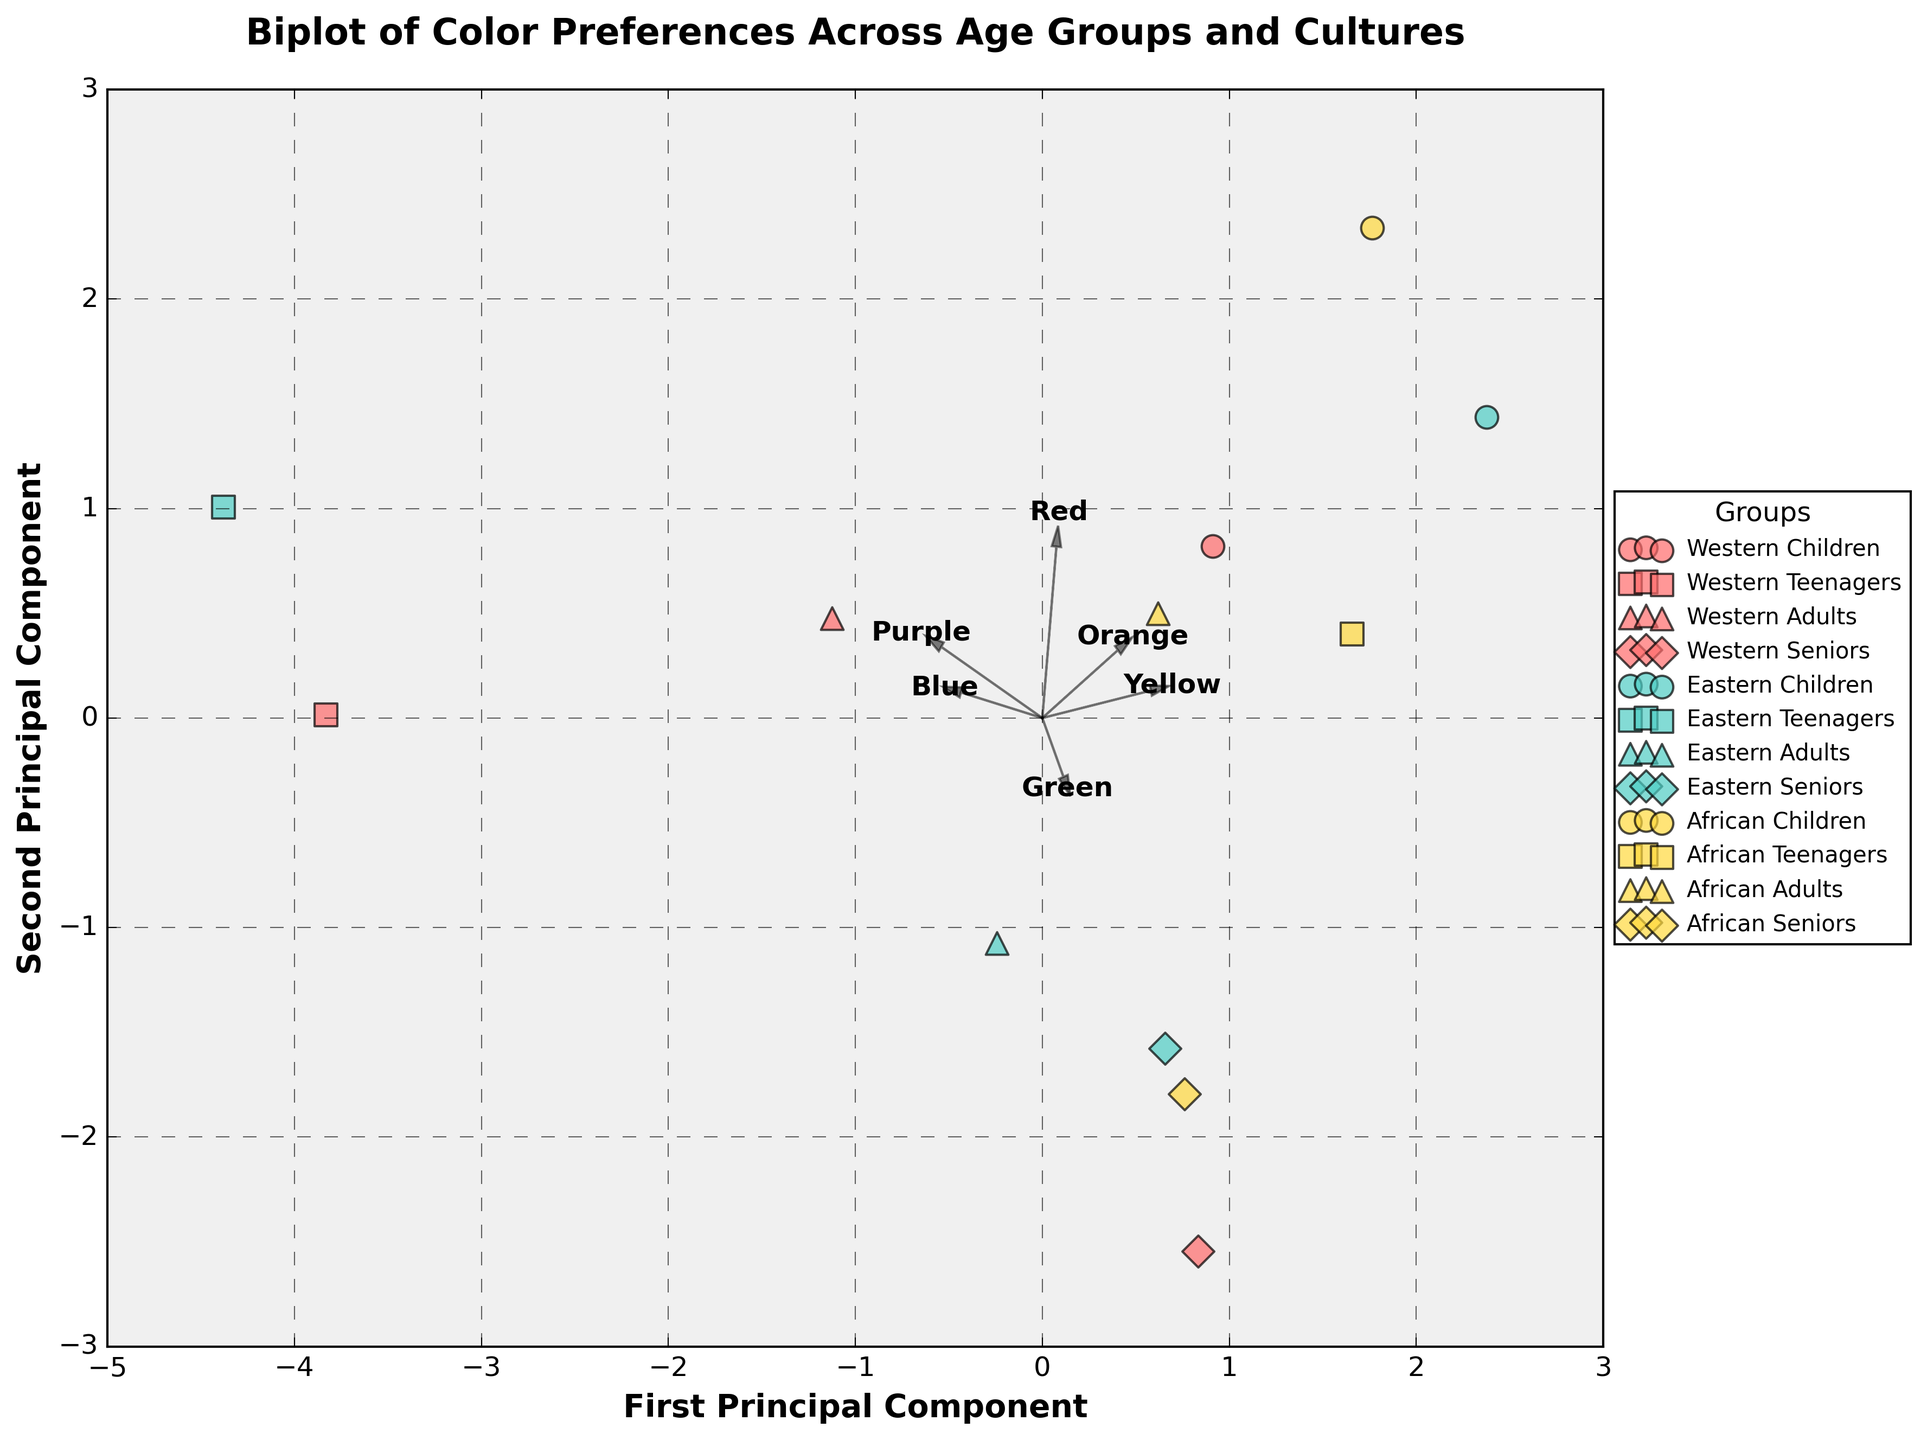what are the two principal components labeled on the axes? The axes are labeled as "First Principal Component" and "Second Principal Component". These components represent the two principal directions in the dataset where the variance is maximized.
Answer: First Principal Component, Second Principal Component How many cultures are represented in the plot? The legend shows three distinct cultures represented by different colors: Western (red), Eastern (teal), and African (yellow).
Answer: Three Which age group and culture combination prefers blue the most? Rows in the plot represent individual points for each combination of age group and culture, and the proximity to the feature vector labeled "Blue" can help identify the preference. The "Teenagers Western" group is closest to the vector for blue.
Answer: Teenagers Western What is the common visual characteristic of the feature arrows? All feature arrows start from the origin (0,0) and point towards their respective directions indicating the contribution of each color preference to the principal components.
Answer: Start from origin Which age group from the African culture is closest to the "Green" vector? Checking the points labeled as African in the figure and identifying their proximity to the "Green" vector, the "Teenagers African" group is nearest to the green vector.
Answer: Teenagers African Which culture shows the most balanced preference across different colors according to the feature vectors' orientation? The "Adults Eastern" group appears relatively central to multiple feature arrows, indicating a more balanced preference across the colors.
Answer: Adults Eastern How do you differentiate between the age groups visually in the plot? Age groups are distinguished using different markers: Children (circle), Teenagers (square), Adults (triangle), and Seniors (diamond). Each age group's marker is applied consistently across the cultures.
Answer: Different markers Are there any overlaps between the cultural groups in the biplot? By analyzing the scatter points, African and Eastern cultures show some overlap in certain age groups, while Western culture clusters are more distinct.
Answer: Yes Which feature vector (color) is most aligned with the first principal component? The feature arrows’ orientation shows how much each color contributes to the principal components. The vector for "Yellow" is most aligned with the first principal component, indicating high influence on the first axis.
Answer: Yellow 